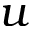<formula> <loc_0><loc_0><loc_500><loc_500>u</formula> 